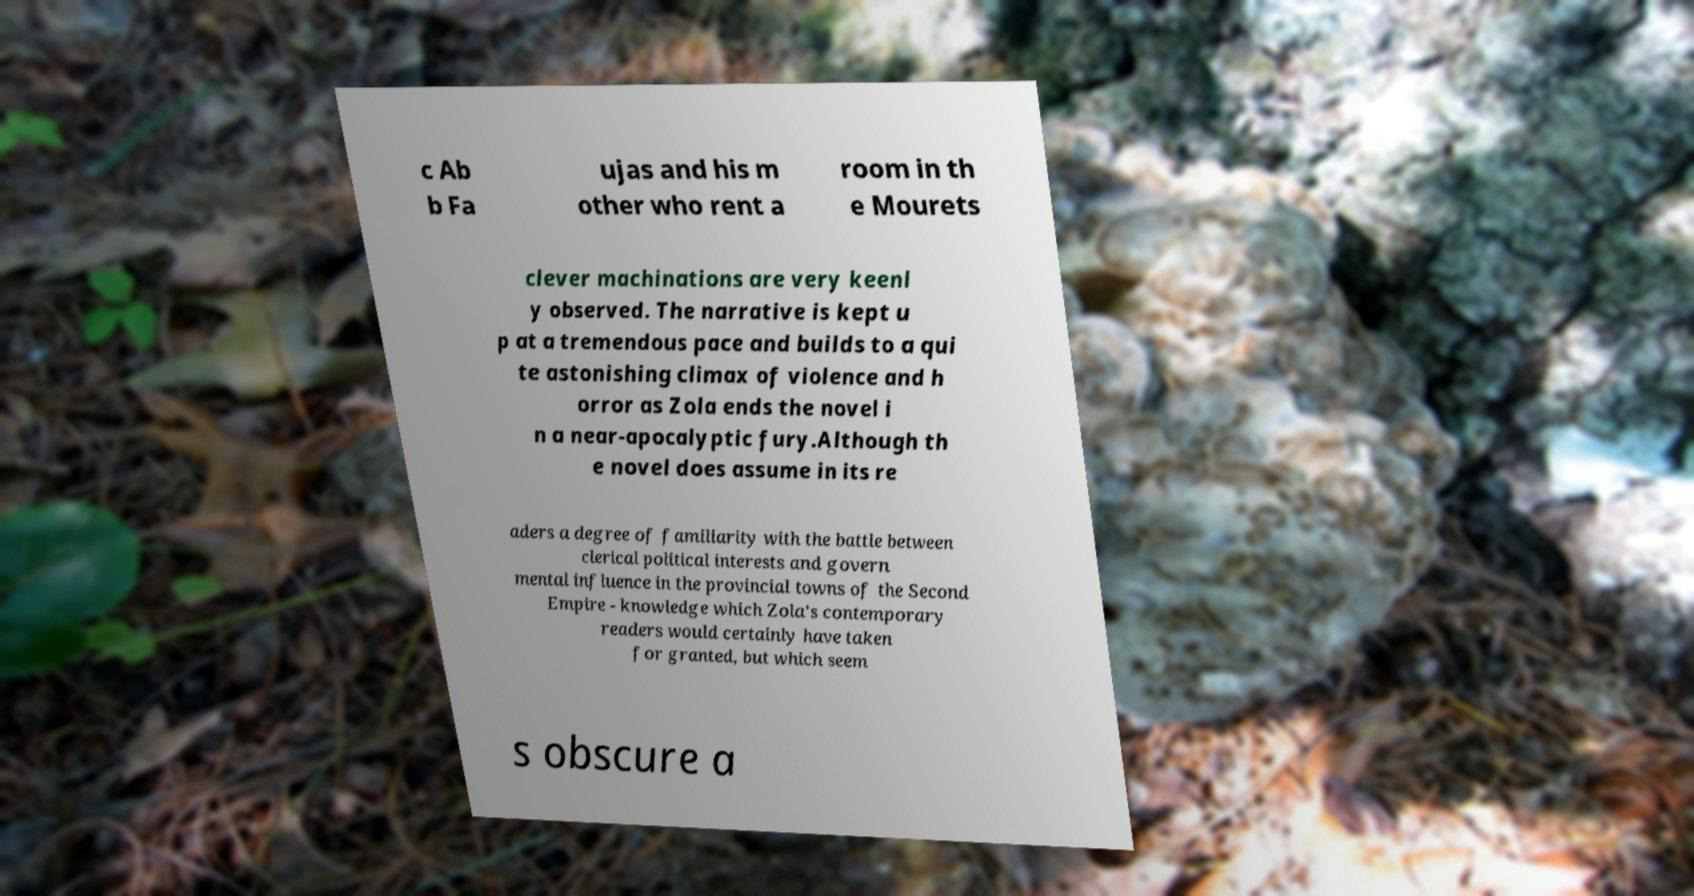Please identify and transcribe the text found in this image. c Ab b Fa ujas and his m other who rent a room in th e Mourets clever machinations are very keenl y observed. The narrative is kept u p at a tremendous pace and builds to a qui te astonishing climax of violence and h orror as Zola ends the novel i n a near-apocalyptic fury.Although th e novel does assume in its re aders a degree of familiarity with the battle between clerical political interests and govern mental influence in the provincial towns of the Second Empire - knowledge which Zola's contemporary readers would certainly have taken for granted, but which seem s obscure a 